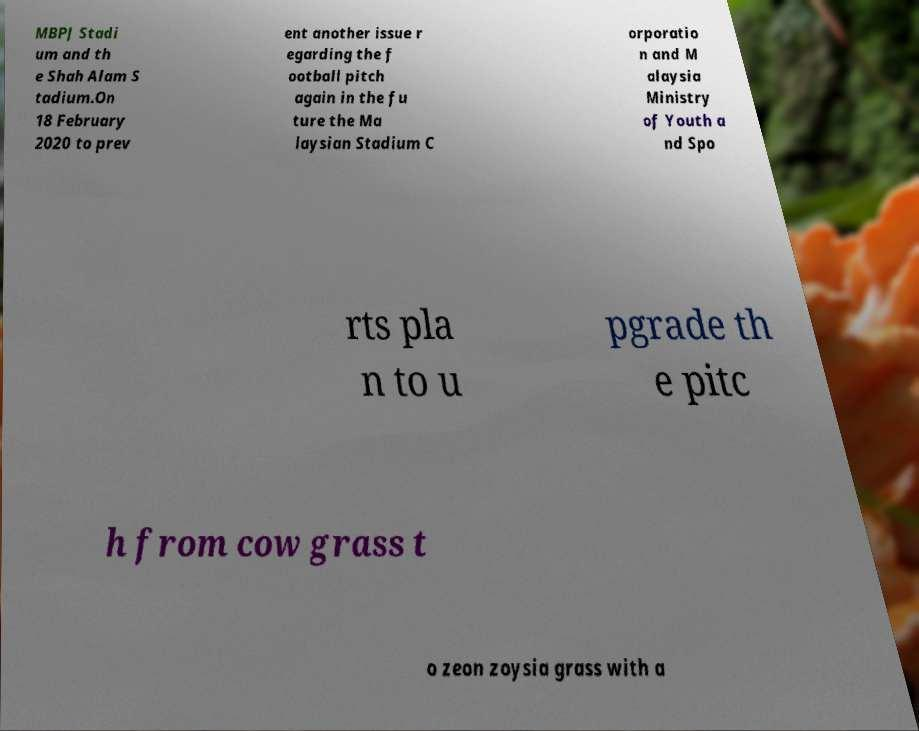What messages or text are displayed in this image? I need them in a readable, typed format. MBPJ Stadi um and th e Shah Alam S tadium.On 18 February 2020 to prev ent another issue r egarding the f ootball pitch again in the fu ture the Ma laysian Stadium C orporatio n and M alaysia Ministry of Youth a nd Spo rts pla n to u pgrade th e pitc h from cow grass t o zeon zoysia grass with a 